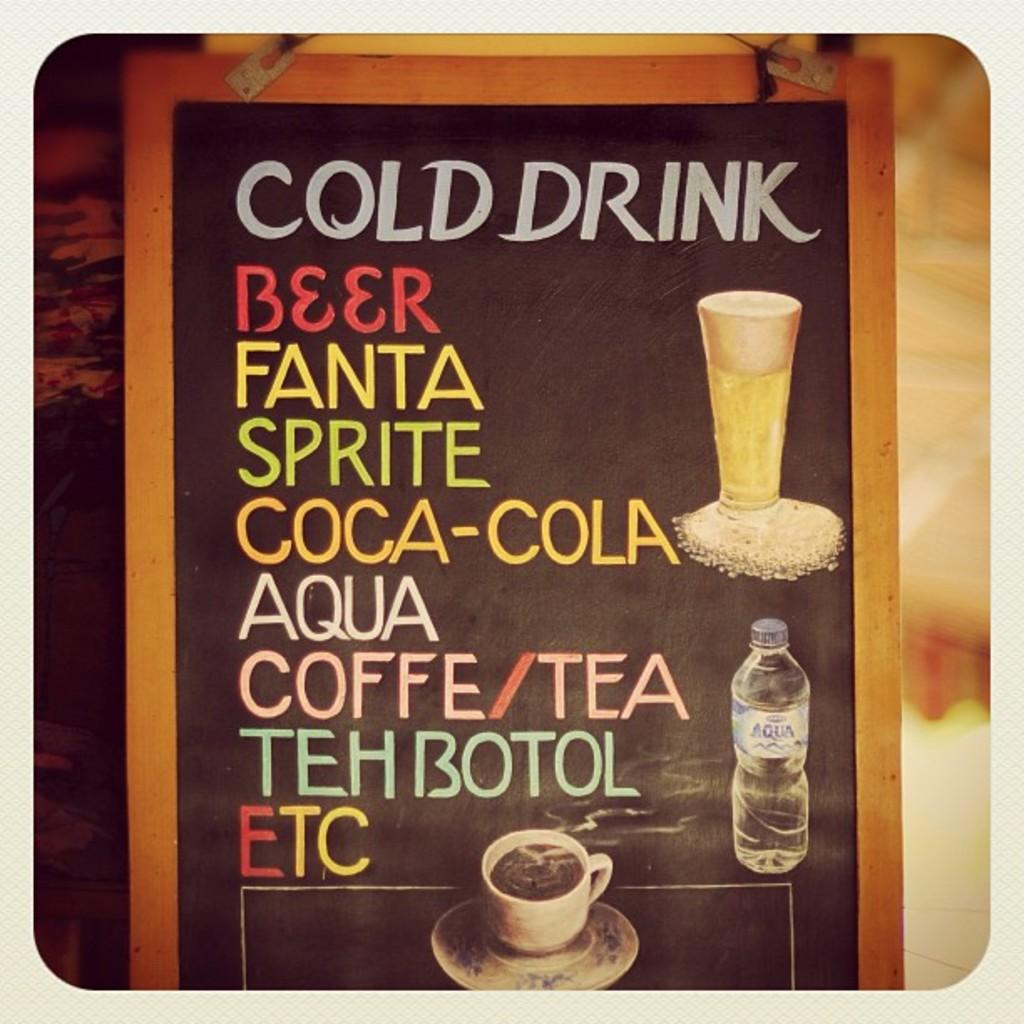<image>
Relay a brief, clear account of the picture shown. A chalkboard sign lists cold drinks including beer, Fanta, Sprite, and other drinks. 